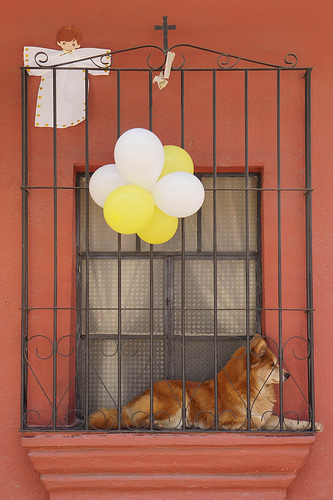<image>
Is the dog under the ballon? Yes. The dog is positioned underneath the ballon, with the ballon above it in the vertical space. 